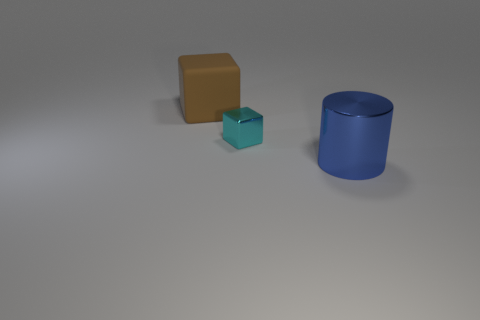There is another object that is the same shape as the brown object; what is its material?
Offer a very short reply. Metal. How many other things are there of the same size as the brown object?
Offer a very short reply. 1. What material is the brown object?
Your response must be concise. Rubber. Are there more things that are on the left side of the metallic cylinder than blue matte spheres?
Your response must be concise. Yes. Is there a blue thing?
Your answer should be very brief. Yes. How many other objects are the same shape as the small cyan object?
Your response must be concise. 1. There is a shiny thing behind the large thing right of the metal thing that is behind the big blue cylinder; what is its size?
Make the answer very short. Small. What shape is the thing that is on the right side of the big brown rubber cube and behind the large blue object?
Offer a terse response. Cube. Are there the same number of big blocks that are on the right side of the blue shiny object and big cylinders that are to the right of the big brown rubber object?
Give a very brief answer. No. Are there any big brown objects that have the same material as the large blue cylinder?
Offer a terse response. No. 